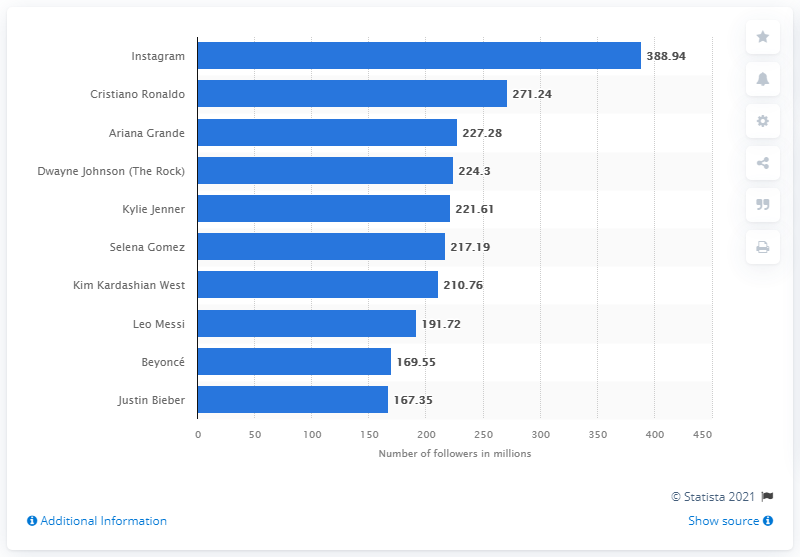List a handful of essential elements in this visual. Cristiano Ronaldo is the most-followed person on Instagram. The top y-axis label in this chart is 'Instagram'. The two Instagram accounts with the closest number of followers in the graph are Beyonce and Justin Bieber. 